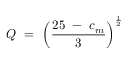Convert formula to latex. <formula><loc_0><loc_0><loc_500><loc_500>Q = \left ( { \frac { 2 5 - c _ { m } } { 3 } } \right ) ^ { \frac { 1 } { 2 } }</formula> 